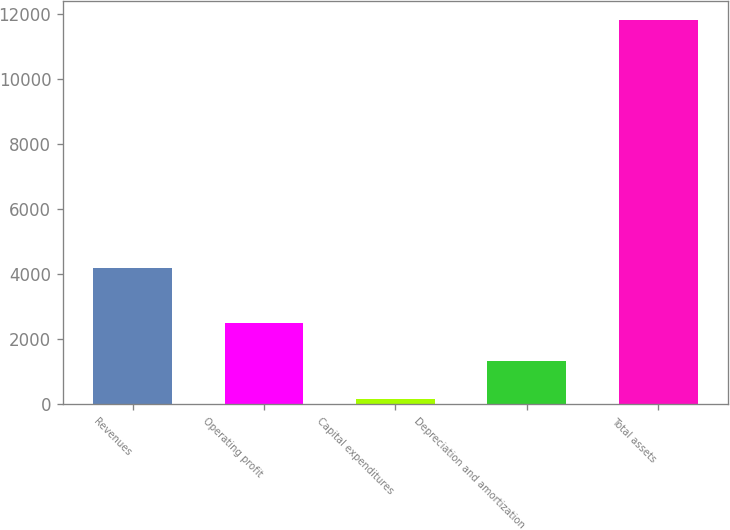<chart> <loc_0><loc_0><loc_500><loc_500><bar_chart><fcel>Revenues<fcel>Operating profit<fcel>Capital expenditures<fcel>Depreciation and amortization<fcel>Total assets<nl><fcel>4182<fcel>2483<fcel>152<fcel>1317.5<fcel>11807<nl></chart> 